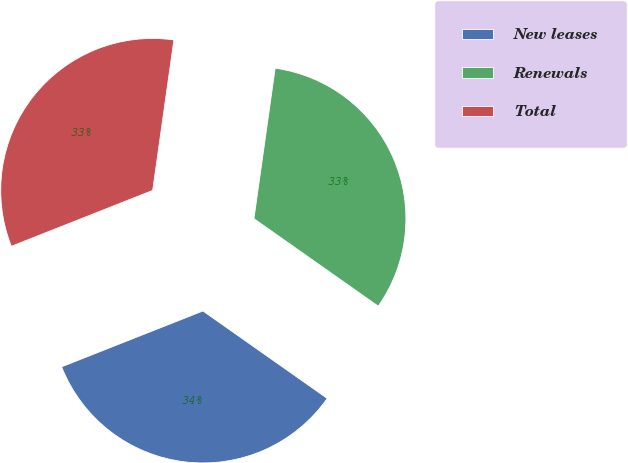Convert chart. <chart><loc_0><loc_0><loc_500><loc_500><pie_chart><fcel>New leases<fcel>Renewals<fcel>Total<nl><fcel>34.25%<fcel>32.53%<fcel>33.22%<nl></chart> 